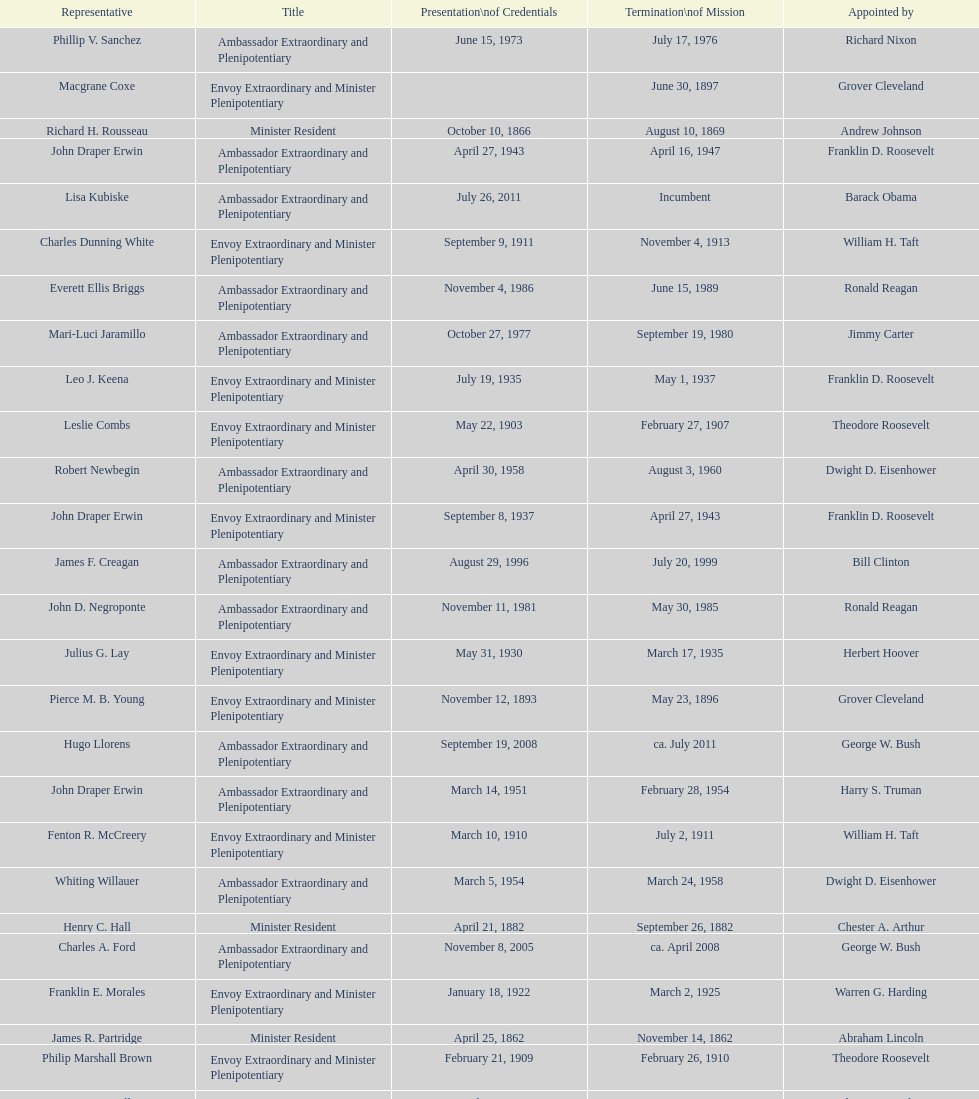Which date is below april 17, 1854 March 17, 1860. 